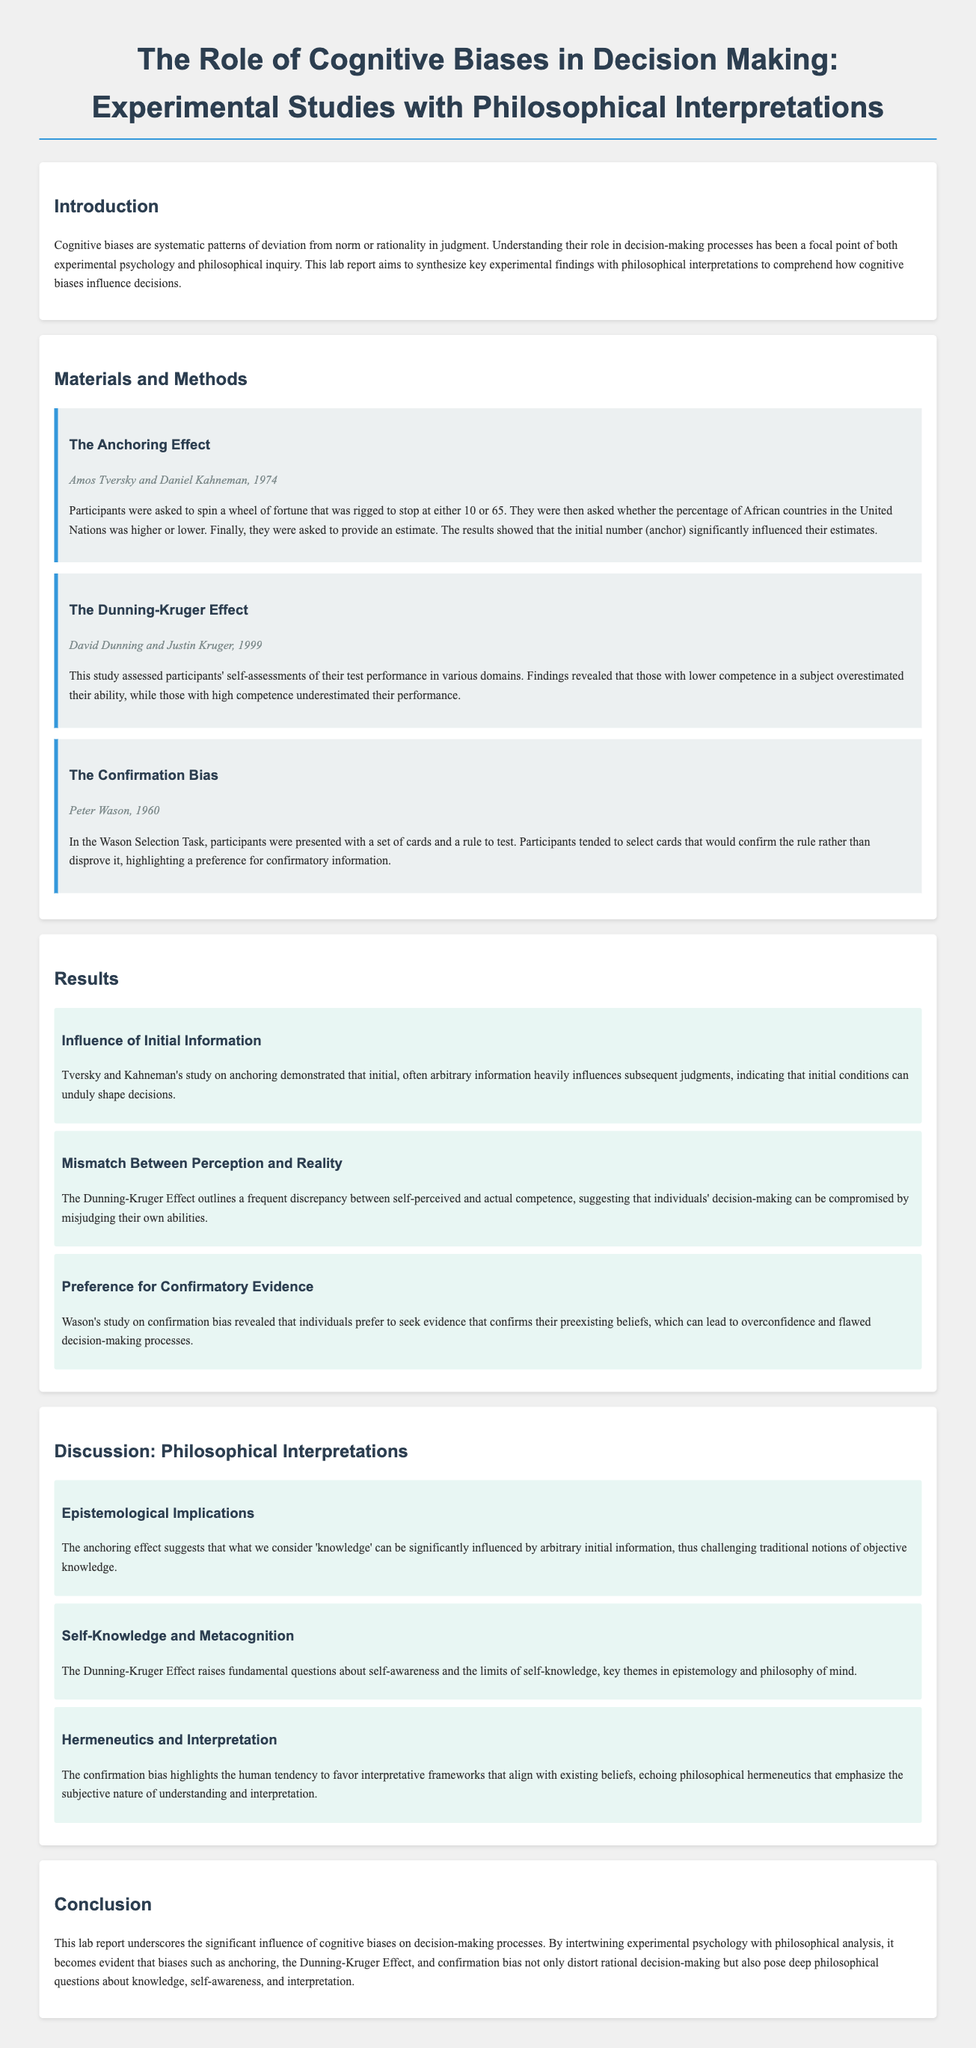What is the main focus of the lab report? The main focus is understanding the role of cognitive biases in decision-making processes.
Answer: Understanding the role of cognitive biases in decision-making processes Who are the authors of the study on the Anchoring Effect? The authors of the study on the Anchoring Effect are cited in the document.
Answer: Amos Tversky and Daniel Kahneman What year was the Dunning-Kruger Effect study conducted? The year of the Dunning-Kruger Effect study is mentioned in the document.
Answer: 1999 What type of bias does the Wason Selection Task demonstrate? The document explains the bias demonstrated in the Wason Selection Task.
Answer: Confirmation Bias What does the Dunning-Kruger Effect highlight about individuals' self-perception? The document discusses what the Dunning-Kruger Effect reveals about self-perception.
Answer: Mismatch Between perception and reality What philosophical theme is questioned due to the Dunning-Kruger Effect? The Dunning-Kruger Effect raises questions about a fundamental philosophical theme.
Answer: Self-awareness and the limits of self-knowledge What is the relationship between cognitive biases and rational decision-making according to the conclusion? The conclusion states how cognitive biases interact with decision-making processes.
Answer: Distort rational decision-making What is one implication of the anchoring effect on knowledge? The document notes an epistemological implication of the anchoring effect on knowledge.
Answer: Influenced by arbitrary initial information 